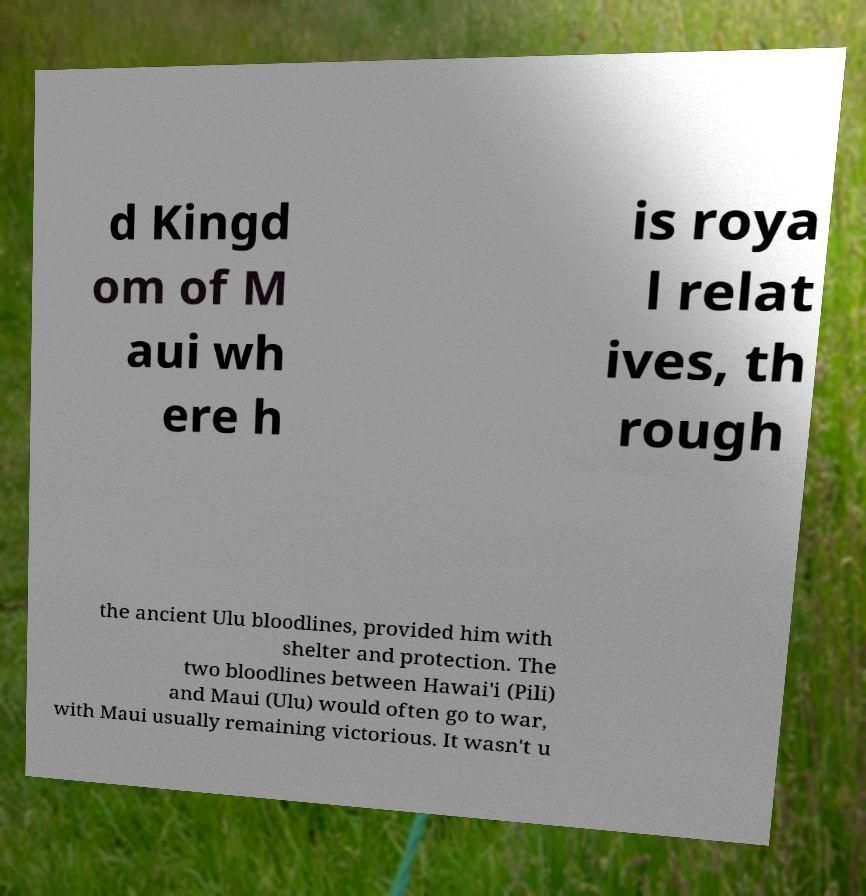Could you assist in decoding the text presented in this image and type it out clearly? d Kingd om of M aui wh ere h is roya l relat ives, th rough the ancient Ulu bloodlines, provided him with shelter and protection. The two bloodlines between Hawai'i (Pili) and Maui (Ulu) would often go to war, with Maui usually remaining victorious. It wasn't u 